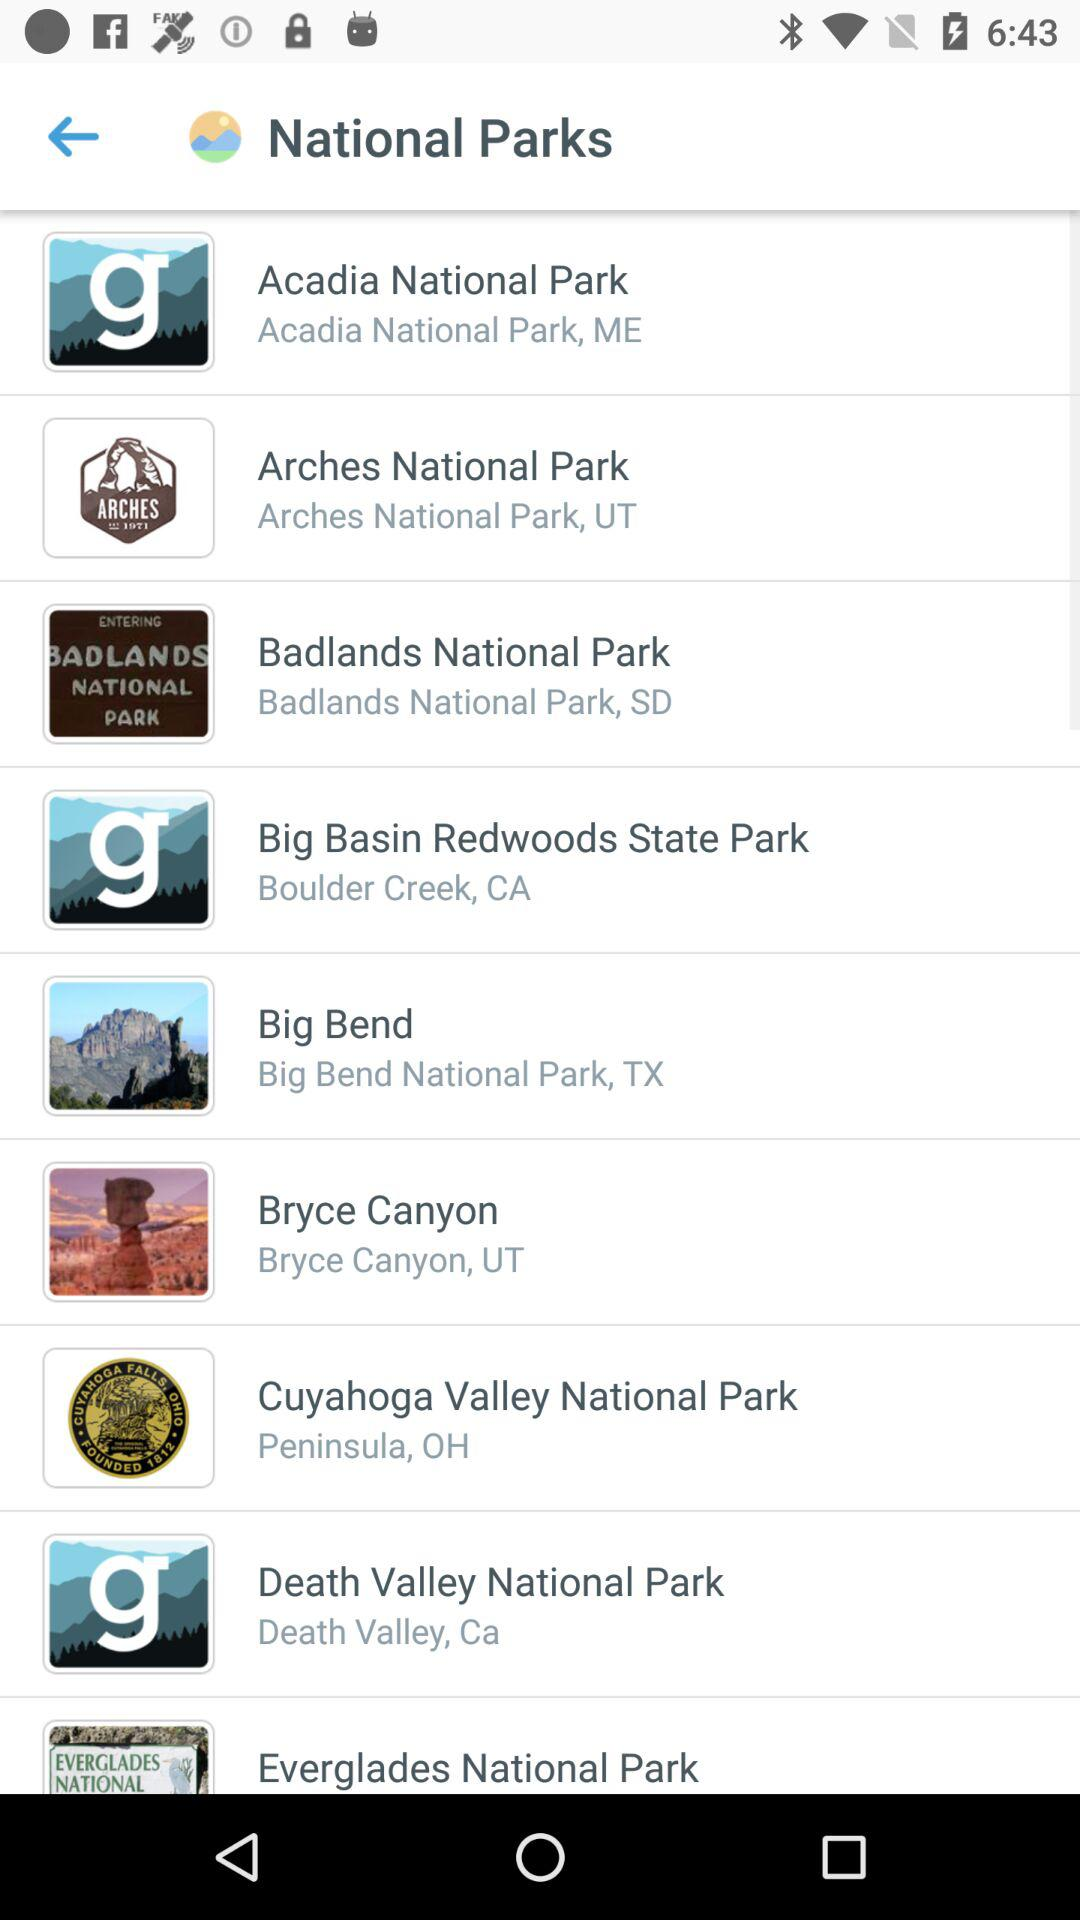What is the address of Cuyahoga Valley National Park? The address of Cuyahoga Valley National Park is Peninsula, OH. 